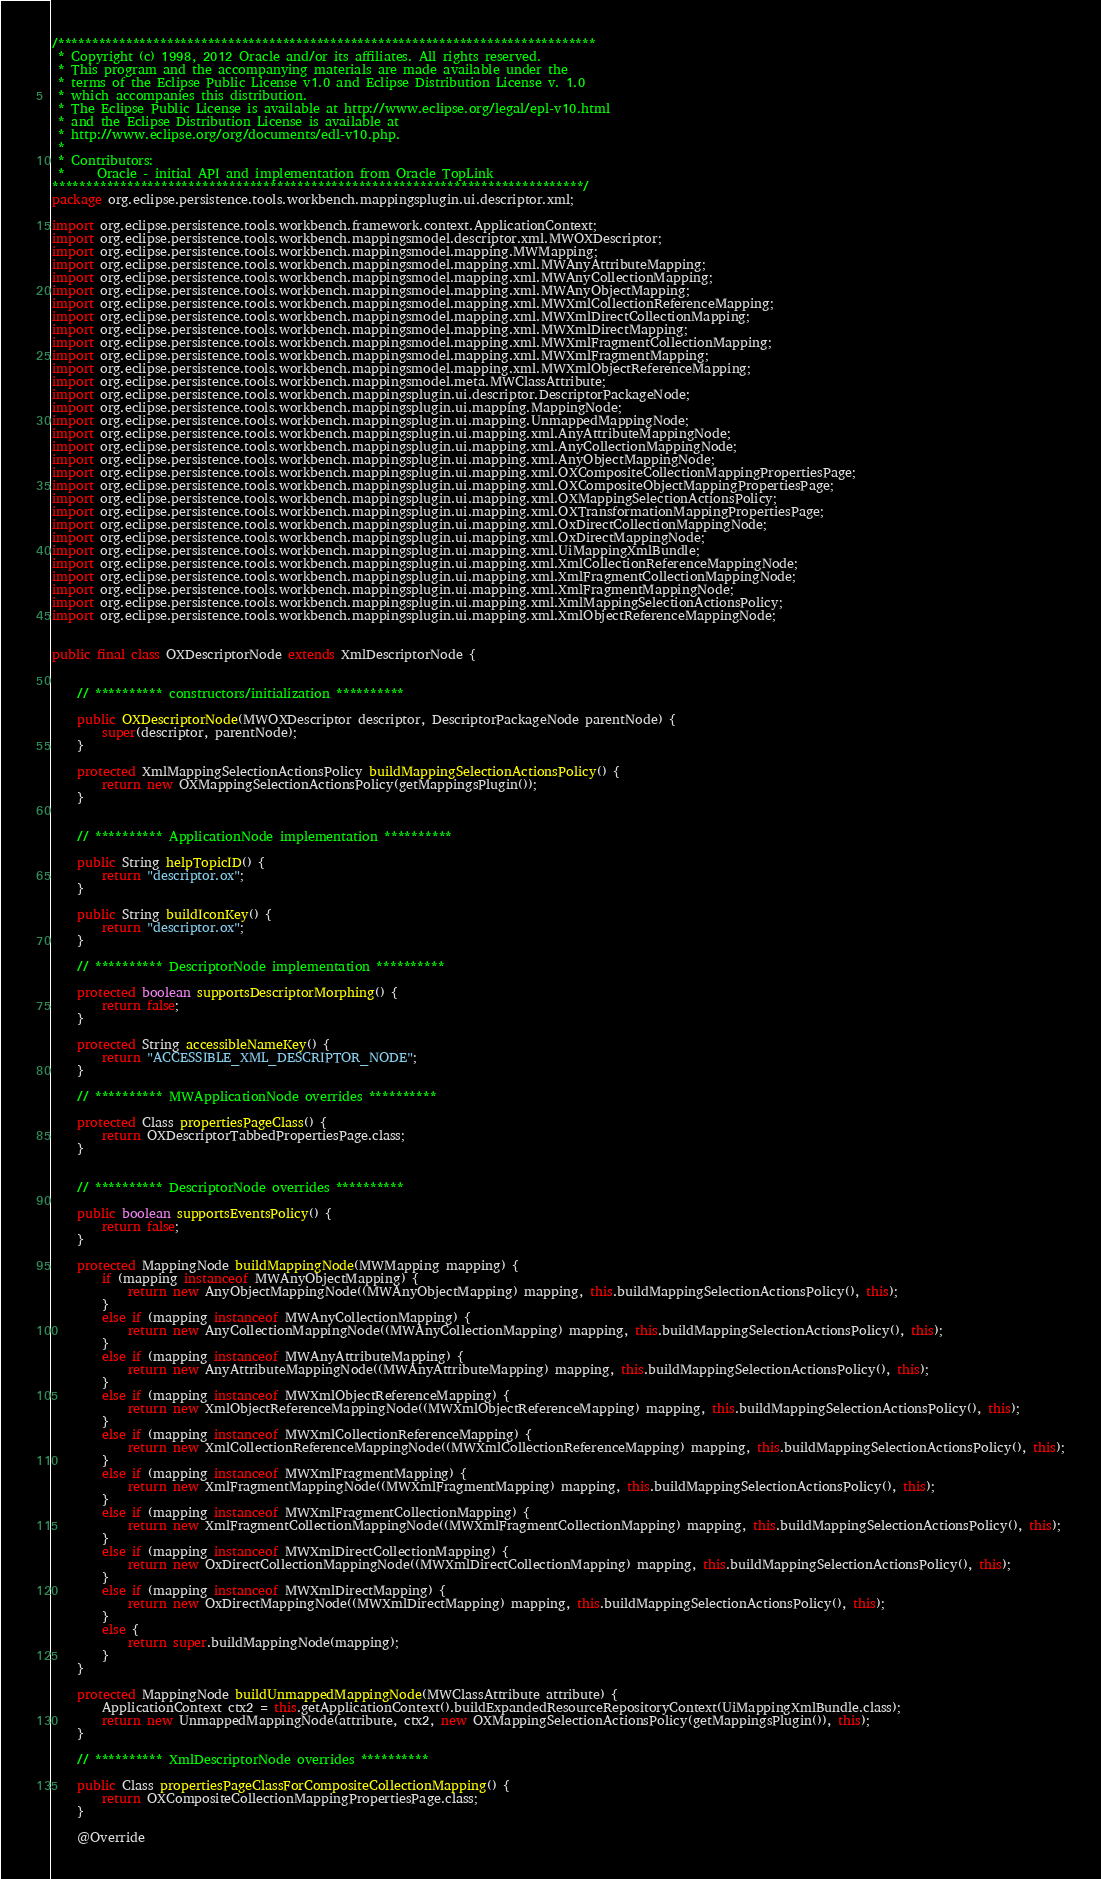Convert code to text. <code><loc_0><loc_0><loc_500><loc_500><_Java_>/*******************************************************************************
 * Copyright (c) 1998, 2012 Oracle and/or its affiliates. All rights reserved.
 * This program and the accompanying materials are made available under the 
 * terms of the Eclipse Public License v1.0 and Eclipse Distribution License v. 1.0 
 * which accompanies this distribution. 
 * The Eclipse Public License is available at http://www.eclipse.org/legal/epl-v10.html
 * and the Eclipse Distribution License is available at 
 * http://www.eclipse.org/org/documents/edl-v10.php.
 *
 * Contributors:
 *     Oracle - initial API and implementation from Oracle TopLink
******************************************************************************/
package org.eclipse.persistence.tools.workbench.mappingsplugin.ui.descriptor.xml;

import org.eclipse.persistence.tools.workbench.framework.context.ApplicationContext;
import org.eclipse.persistence.tools.workbench.mappingsmodel.descriptor.xml.MWOXDescriptor;
import org.eclipse.persistence.tools.workbench.mappingsmodel.mapping.MWMapping;
import org.eclipse.persistence.tools.workbench.mappingsmodel.mapping.xml.MWAnyAttributeMapping;
import org.eclipse.persistence.tools.workbench.mappingsmodel.mapping.xml.MWAnyCollectionMapping;
import org.eclipse.persistence.tools.workbench.mappingsmodel.mapping.xml.MWAnyObjectMapping;
import org.eclipse.persistence.tools.workbench.mappingsmodel.mapping.xml.MWXmlCollectionReferenceMapping;
import org.eclipse.persistence.tools.workbench.mappingsmodel.mapping.xml.MWXmlDirectCollectionMapping;
import org.eclipse.persistence.tools.workbench.mappingsmodel.mapping.xml.MWXmlDirectMapping;
import org.eclipse.persistence.tools.workbench.mappingsmodel.mapping.xml.MWXmlFragmentCollectionMapping;
import org.eclipse.persistence.tools.workbench.mappingsmodel.mapping.xml.MWXmlFragmentMapping;
import org.eclipse.persistence.tools.workbench.mappingsmodel.mapping.xml.MWXmlObjectReferenceMapping;
import org.eclipse.persistence.tools.workbench.mappingsmodel.meta.MWClassAttribute;
import org.eclipse.persistence.tools.workbench.mappingsplugin.ui.descriptor.DescriptorPackageNode;
import org.eclipse.persistence.tools.workbench.mappingsplugin.ui.mapping.MappingNode;
import org.eclipse.persistence.tools.workbench.mappingsplugin.ui.mapping.UnmappedMappingNode;
import org.eclipse.persistence.tools.workbench.mappingsplugin.ui.mapping.xml.AnyAttributeMappingNode;
import org.eclipse.persistence.tools.workbench.mappingsplugin.ui.mapping.xml.AnyCollectionMappingNode;
import org.eclipse.persistence.tools.workbench.mappingsplugin.ui.mapping.xml.AnyObjectMappingNode;
import org.eclipse.persistence.tools.workbench.mappingsplugin.ui.mapping.xml.OXCompositeCollectionMappingPropertiesPage;
import org.eclipse.persistence.tools.workbench.mappingsplugin.ui.mapping.xml.OXCompositeObjectMappingPropertiesPage;
import org.eclipse.persistence.tools.workbench.mappingsplugin.ui.mapping.xml.OXMappingSelectionActionsPolicy;
import org.eclipse.persistence.tools.workbench.mappingsplugin.ui.mapping.xml.OXTransformationMappingPropertiesPage;
import org.eclipse.persistence.tools.workbench.mappingsplugin.ui.mapping.xml.OxDirectCollectionMappingNode;
import org.eclipse.persistence.tools.workbench.mappingsplugin.ui.mapping.xml.OxDirectMappingNode;
import org.eclipse.persistence.tools.workbench.mappingsplugin.ui.mapping.xml.UiMappingXmlBundle;
import org.eclipse.persistence.tools.workbench.mappingsplugin.ui.mapping.xml.XmlCollectionReferenceMappingNode;
import org.eclipse.persistence.tools.workbench.mappingsplugin.ui.mapping.xml.XmlFragmentCollectionMappingNode;
import org.eclipse.persistence.tools.workbench.mappingsplugin.ui.mapping.xml.XmlFragmentMappingNode;
import org.eclipse.persistence.tools.workbench.mappingsplugin.ui.mapping.xml.XmlMappingSelectionActionsPolicy;
import org.eclipse.persistence.tools.workbench.mappingsplugin.ui.mapping.xml.XmlObjectReferenceMappingNode;


public final class OXDescriptorNode extends XmlDescriptorNode {


	// ********** constructors/initialization **********
	
	public OXDescriptorNode(MWOXDescriptor descriptor, DescriptorPackageNode parentNode) {
		super(descriptor, parentNode);
	}
		
	protected XmlMappingSelectionActionsPolicy buildMappingSelectionActionsPolicy() {
		return new OXMappingSelectionActionsPolicy(getMappingsPlugin());
	}
	
	
	// ********** ApplicationNode implementation **********

	public String helpTopicID() {
		return "descriptor.ox";
	}

	public String buildIconKey() {
		return "descriptor.ox";
	}

	// ********** DescriptorNode implementation **********

	protected boolean supportsDescriptorMorphing() {
		return false;
	}

	protected String accessibleNameKey() {
		return "ACCESSIBLE_XML_DESCRIPTOR_NODE";
	}

	// ********** MWApplicationNode overrides **********

	protected Class propertiesPageClass() {
		return OXDescriptorTabbedPropertiesPage.class;
	}

	
	// ********** DescriptorNode overrides **********
	
	public boolean supportsEventsPolicy() {
		return false;
	}
	
	protected MappingNode buildMappingNode(MWMapping mapping) {
		if (mapping instanceof MWAnyObjectMapping) {
			return new AnyObjectMappingNode((MWAnyObjectMapping) mapping, this.buildMappingSelectionActionsPolicy(), this);
		}
		else if (mapping instanceof MWAnyCollectionMapping) {
			return new AnyCollectionMappingNode((MWAnyCollectionMapping) mapping, this.buildMappingSelectionActionsPolicy(), this);
		}
		else if (mapping instanceof MWAnyAttributeMapping) {
			return new AnyAttributeMappingNode((MWAnyAttributeMapping) mapping, this.buildMappingSelectionActionsPolicy(), this);
		}
		else if (mapping instanceof MWXmlObjectReferenceMapping) {
			return new XmlObjectReferenceMappingNode((MWXmlObjectReferenceMapping) mapping, this.buildMappingSelectionActionsPolicy(), this);
		}
		else if (mapping instanceof MWXmlCollectionReferenceMapping) {
			return new XmlCollectionReferenceMappingNode((MWXmlCollectionReferenceMapping) mapping, this.buildMappingSelectionActionsPolicy(), this);
		}
		else if (mapping instanceof MWXmlFragmentMapping) {
			return new XmlFragmentMappingNode((MWXmlFragmentMapping) mapping, this.buildMappingSelectionActionsPolicy(), this);
		}
		else if (mapping instanceof MWXmlFragmentCollectionMapping) {
			return new XmlFragmentCollectionMappingNode((MWXmlFragmentCollectionMapping) mapping, this.buildMappingSelectionActionsPolicy(), this);
		}
		else if (mapping instanceof MWXmlDirectCollectionMapping) {
			return new OxDirectCollectionMappingNode((MWXmlDirectCollectionMapping) mapping, this.buildMappingSelectionActionsPolicy(), this);
		}		
		else if (mapping instanceof MWXmlDirectMapping) {
			return new OxDirectMappingNode((MWXmlDirectMapping) mapping, this.buildMappingSelectionActionsPolicy(), this);
		}		
		else {
			return super.buildMappingNode(mapping);
		}
	}
	
	protected MappingNode buildUnmappedMappingNode(MWClassAttribute attribute) {
		ApplicationContext ctx2 = this.getApplicationContext().buildExpandedResourceRepositoryContext(UiMappingXmlBundle.class);
		return new UnmappedMappingNode(attribute, ctx2, new OXMappingSelectionActionsPolicy(getMappingsPlugin()), this);
	}

	// ********** XmlDescriptorNode overrides **********

	public Class propertiesPageClassForCompositeCollectionMapping() {
		return OXCompositeCollectionMappingPropertiesPage.class;
	}

	@Override</code> 